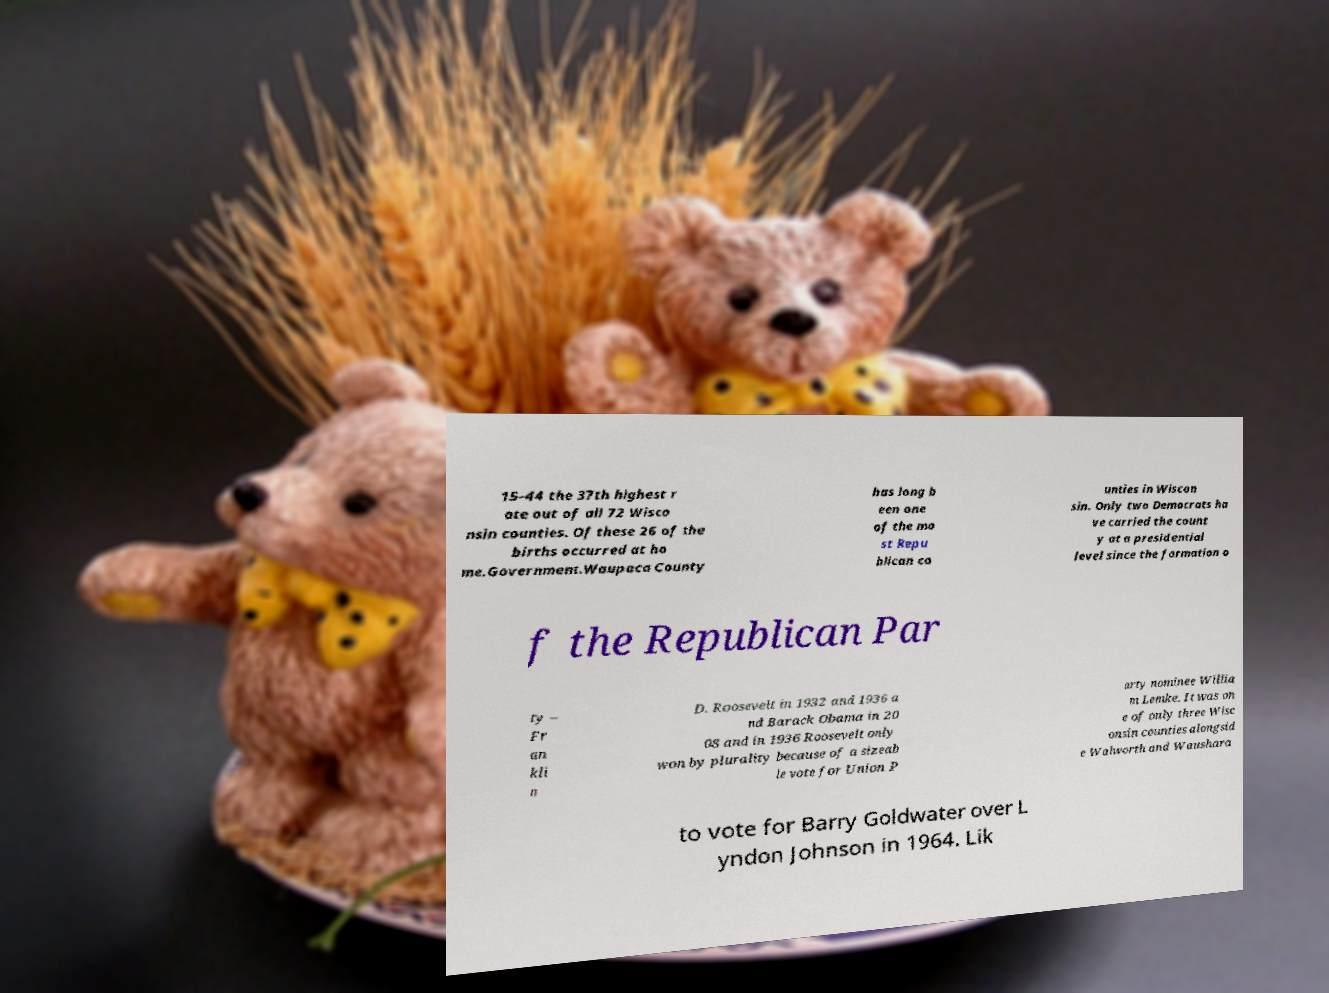Please read and relay the text visible in this image. What does it say? 15–44 the 37th highest r ate out of all 72 Wisco nsin counties. Of these 26 of the births occurred at ho me.Government.Waupaca County has long b een one of the mo st Repu blican co unties in Wiscon sin. Only two Democrats ha ve carried the count y at a presidential level since the formation o f the Republican Par ty – Fr an kli n D. Roosevelt in 1932 and 1936 a nd Barack Obama in 20 08 and in 1936 Roosevelt only won by plurality because of a sizeab le vote for Union P arty nominee Willia m Lemke. It was on e of only three Wisc onsin counties alongsid e Walworth and Waushara to vote for Barry Goldwater over L yndon Johnson in 1964. Lik 